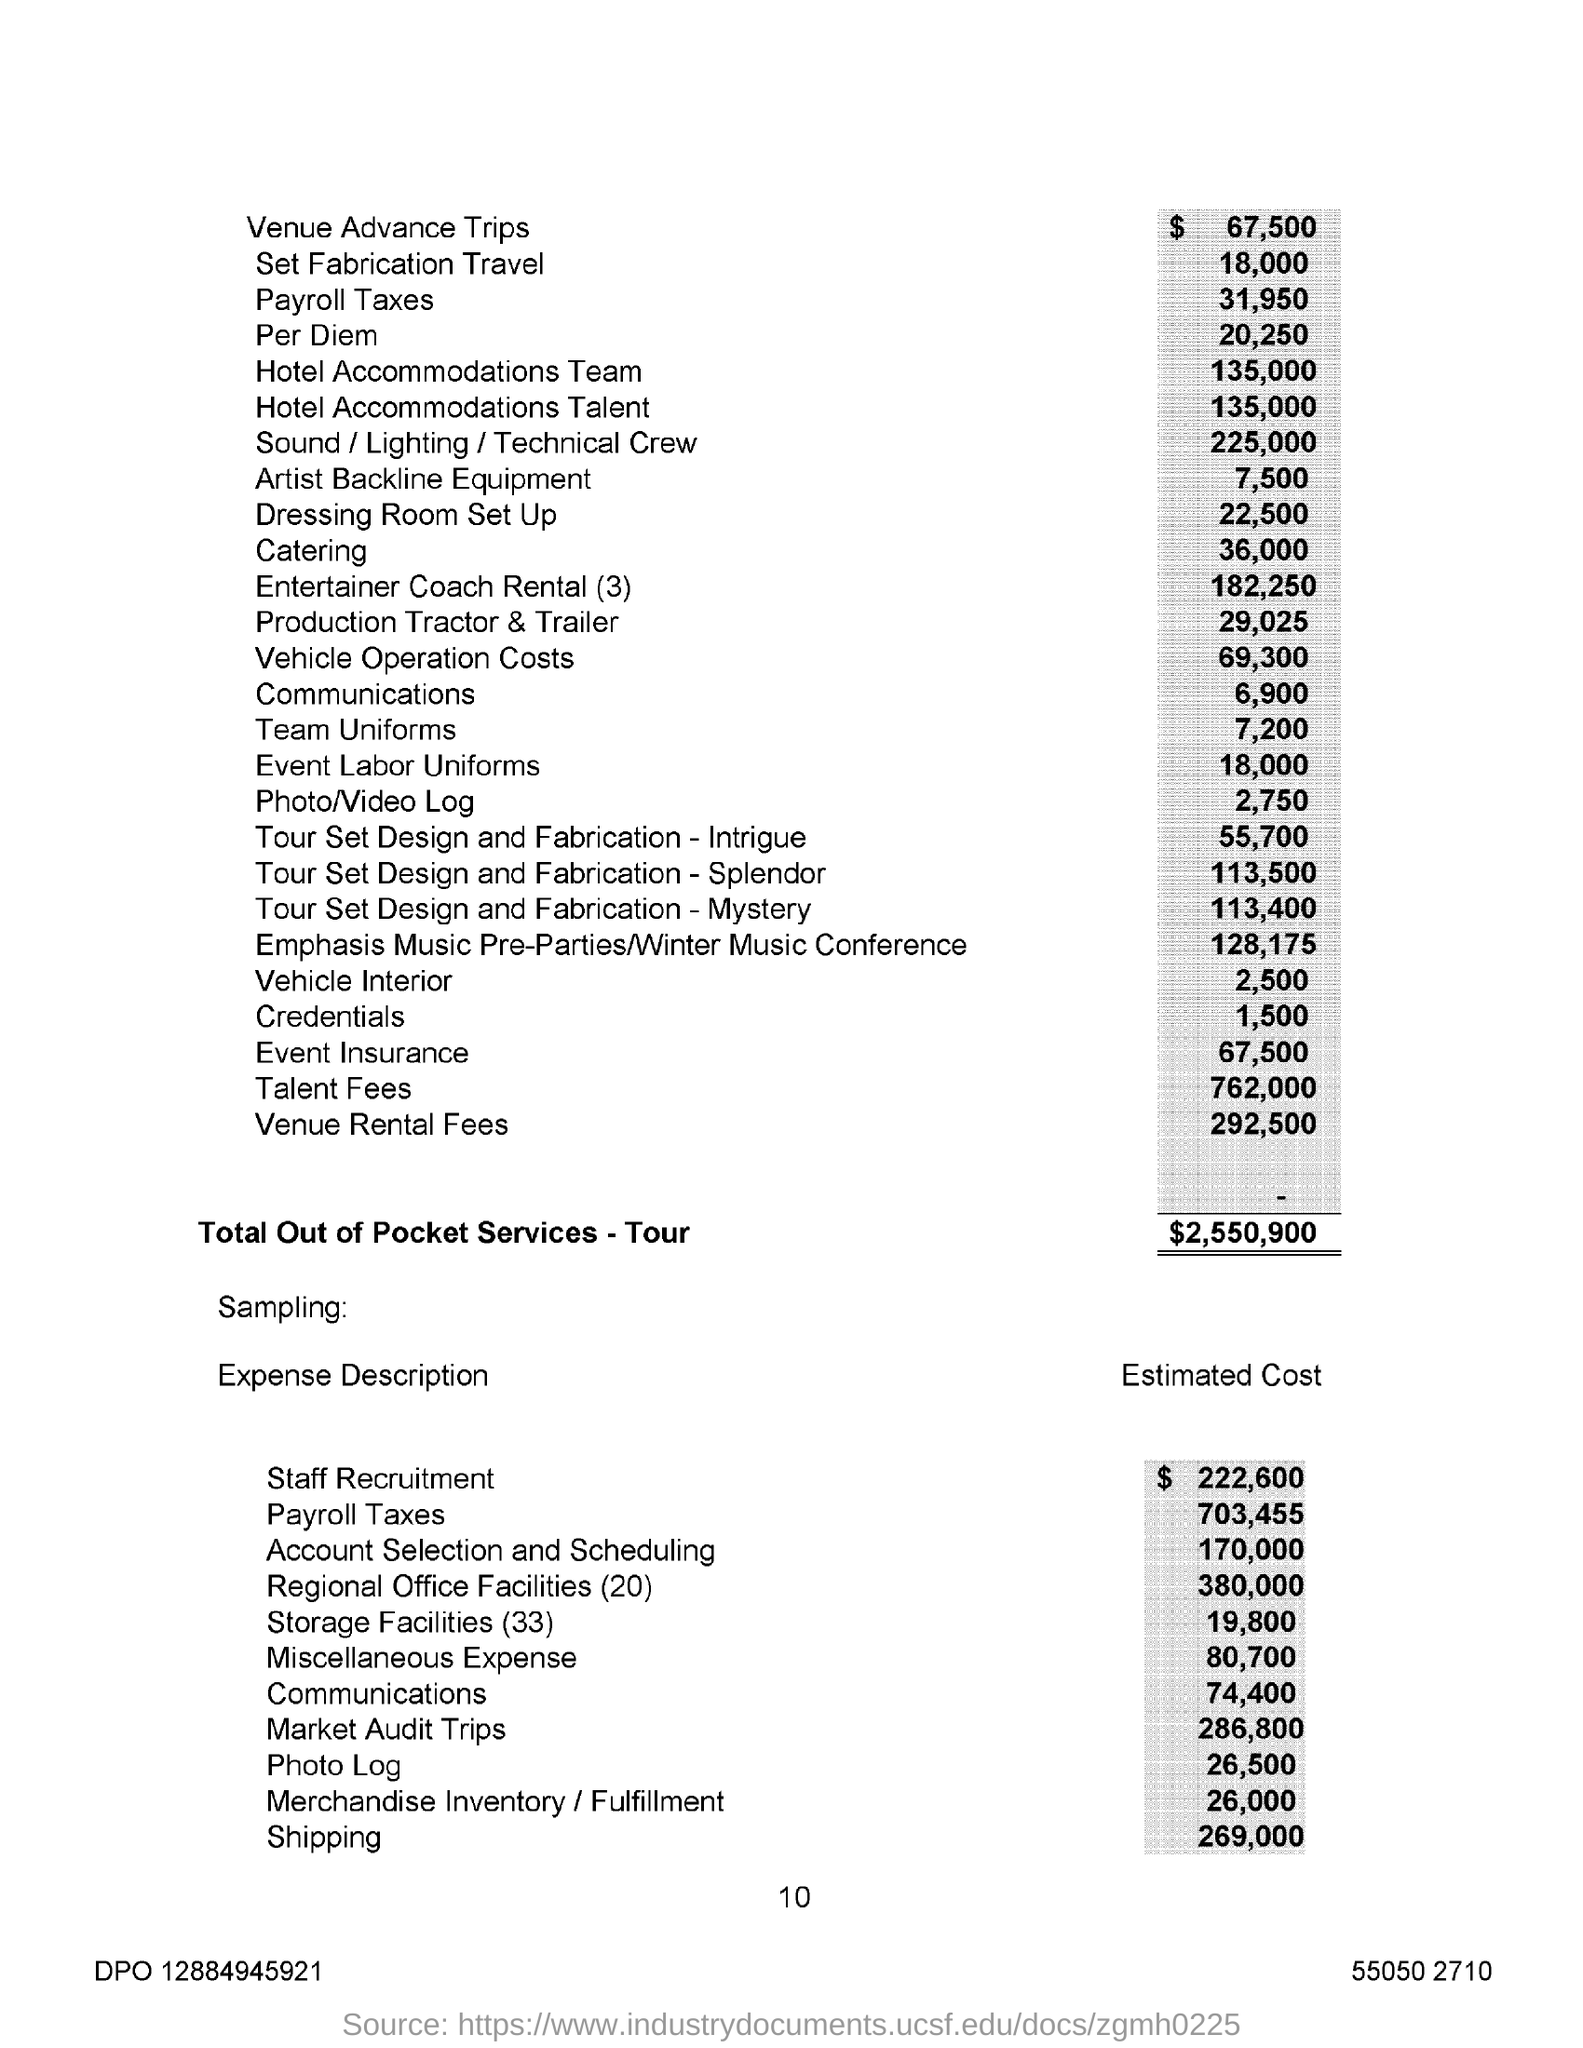What is Total Out of Pocket Services - Tour?
Keep it short and to the point. $2,550,900. What is the "Estimated Cost" for "Shipping"?
Provide a succinct answer. 269,000. 